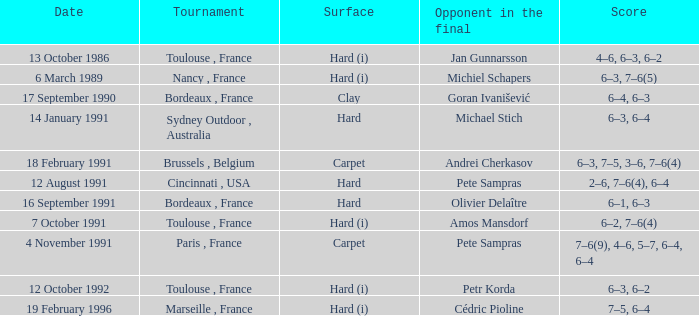What is the surface of the tournament with cédric pioline as the opponent in the final? Hard (i). 